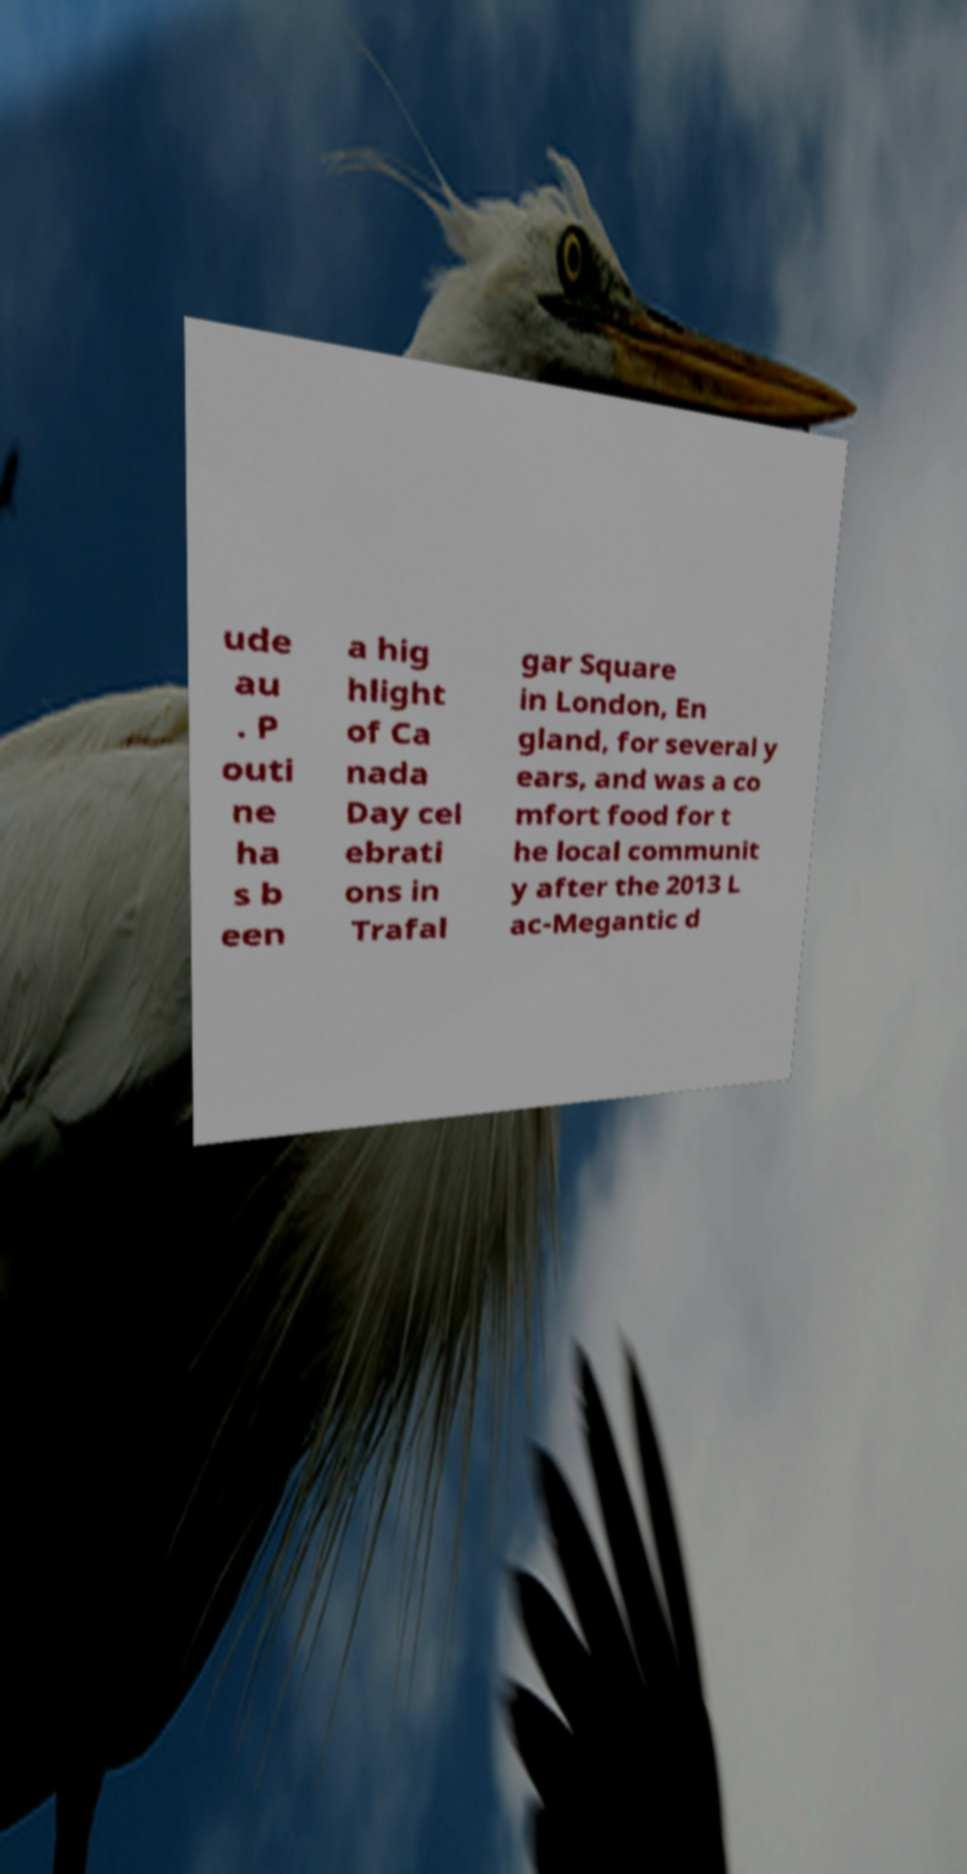Please identify and transcribe the text found in this image. ude au . P outi ne ha s b een a hig hlight of Ca nada Day cel ebrati ons in Trafal gar Square in London, En gland, for several y ears, and was a co mfort food for t he local communit y after the 2013 L ac-Megantic d 